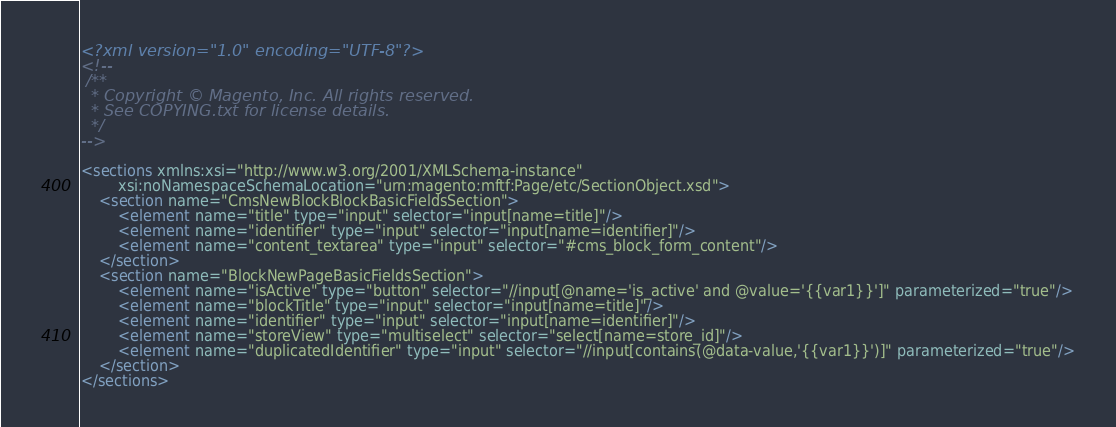Convert code to text. <code><loc_0><loc_0><loc_500><loc_500><_XML_><?xml version="1.0" encoding="UTF-8"?>
<!--
 /**
  * Copyright © Magento, Inc. All rights reserved.
  * See COPYING.txt for license details.
  */
-->

<sections xmlns:xsi="http://www.w3.org/2001/XMLSchema-instance"
        xsi:noNamespaceSchemaLocation="urn:magento:mftf:Page/etc/SectionObject.xsd">
    <section name="CmsNewBlockBlockBasicFieldsSection">
        <element name="title" type="input" selector="input[name=title]"/>
        <element name="identifier" type="input" selector="input[name=identifier]"/>
        <element name="content_textarea" type="input" selector="#cms_block_form_content"/>
    </section>
    <section name="BlockNewPageBasicFieldsSection">
        <element name="isActive" type="button" selector="//input[@name='is_active' and @value='{{var1}}']" parameterized="true"/>
        <element name="blockTitle" type="input" selector="input[name=title]"/>
        <element name="identifier" type="input" selector="input[name=identifier]"/>
        <element name="storeView" type="multiselect" selector="select[name=store_id]"/>
        <element name="duplicatedIdentifier" type="input" selector="//input[contains(@data-value,'{{var1}}')]" parameterized="true"/>
    </section>
</sections>
</code> 